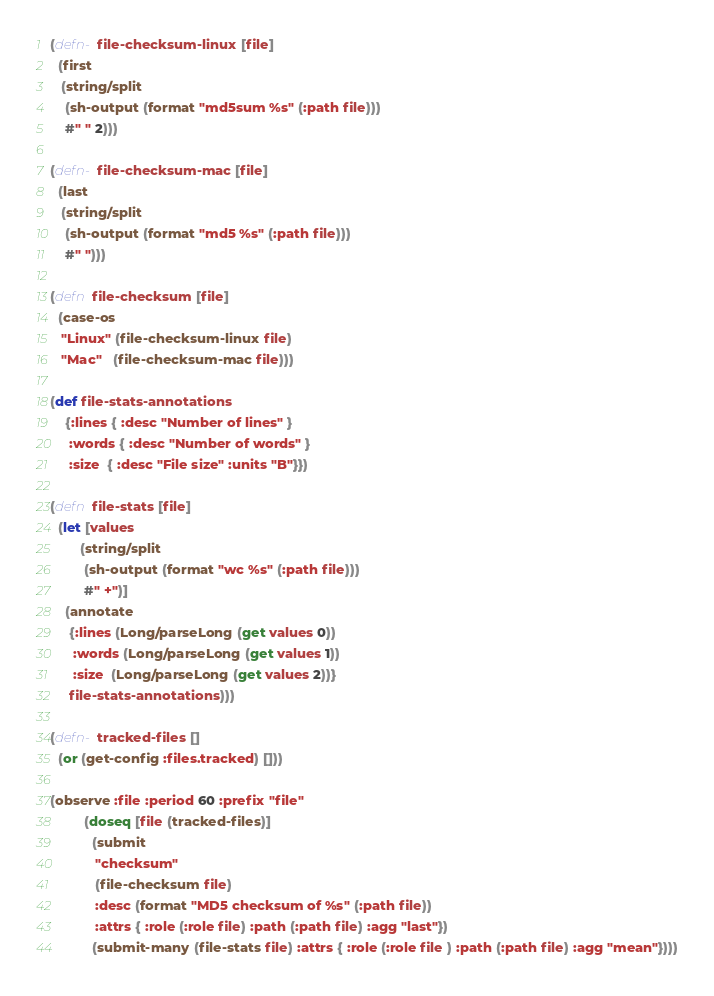<code> <loc_0><loc_0><loc_500><loc_500><_Clojure_>(defn- file-checksum-linux [file]
  (first
   (string/split
    (sh-output (format "md5sum %s" (:path file)))
    #" " 2)))

(defn- file-checksum-mac [file]
  (last
   (string/split
    (sh-output (format "md5 %s" (:path file)))
    #" ")))

(defn file-checksum [file]
  (case-os
   "Linux" (file-checksum-linux file)
   "Mac"   (file-checksum-mac file)))

(def file-stats-annotations
    {:lines { :desc "Number of lines" }
     :words { :desc "Number of words" }
     :size  { :desc "File size" :units "B"}})

(defn file-stats [file]
  (let [values
        (string/split
         (sh-output (format "wc %s" (:path file)))
         #" +")]
    (annotate
     {:lines (Long/parseLong (get values 0))
      :words (Long/parseLong (get values 1))
      :size  (Long/parseLong (get values 2))}
     file-stats-annotations)))

(defn- tracked-files []
  (or (get-config :files.tracked) []))

(observe :file :period 60 :prefix "file"
         (doseq [file (tracked-files)]
           (submit
            "checksum"
            (file-checksum file)
            :desc (format "MD5 checksum of %s" (:path file))
            :attrs { :role (:role file) :path (:path file) :agg "last"})
           (submit-many (file-stats file) :attrs { :role (:role file ) :path (:path file) :agg "mean"})))
</code> 